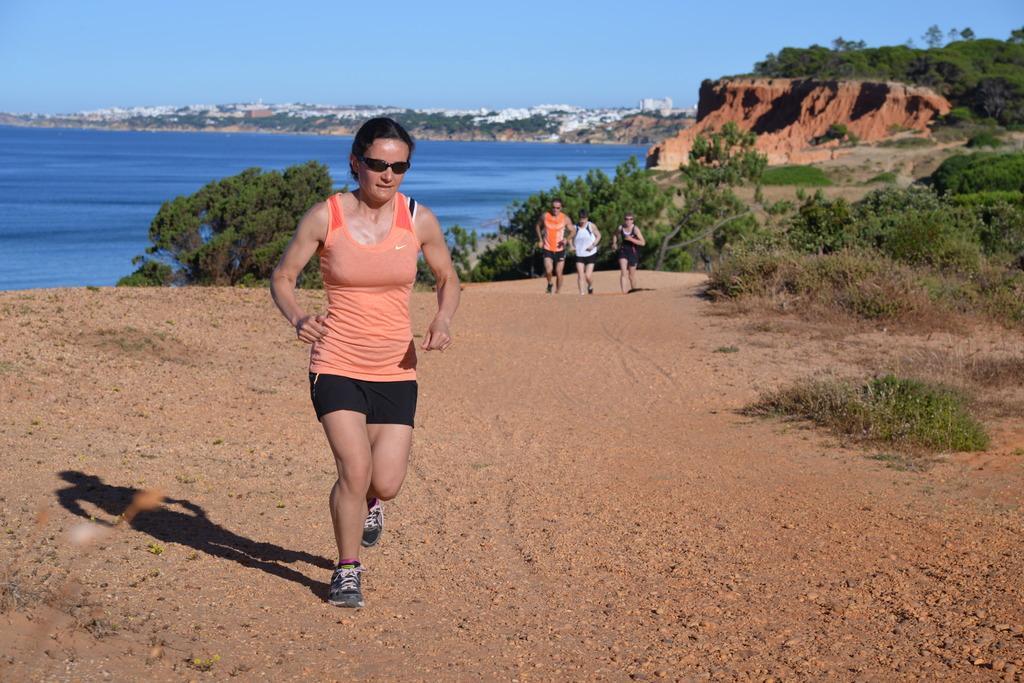Could you give a brief overview of what you see in this image? In this image I see a woman who is wearing orange tank top and black shorts and I see that she is wearing black shades and I see the ground on which there are grass and plants. In the background I see the trees and 3 persons over here and I see the water over here and I see the blue sky. p 